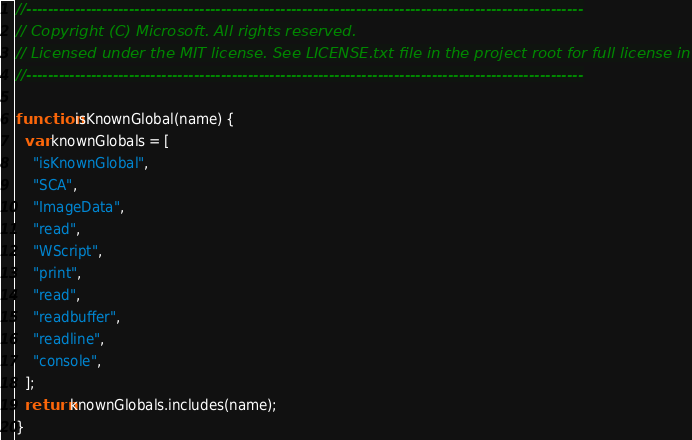Convert code to text. <code><loc_0><loc_0><loc_500><loc_500><_JavaScript_>//-------------------------------------------------------------------------------------------------------
// Copyright (C) Microsoft. All rights reserved.
// Licensed under the MIT license. See LICENSE.txt file in the project root for full license information.
//-------------------------------------------------------------------------------------------------------

function isKnownGlobal(name) {
  var knownGlobals = [
    "isKnownGlobal",
    "SCA",
    "ImageData",
    "read",
    "WScript",
    "print",
    "read",
    "readbuffer",
    "readline",
    "console",
  ];
  return knownGlobals.includes(name);
}
</code> 